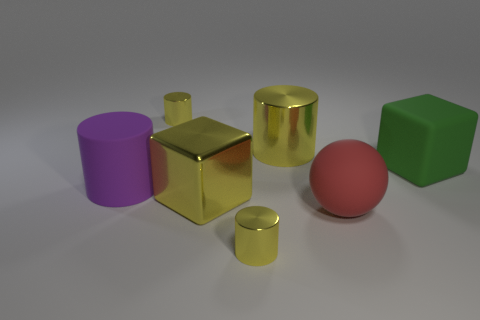How many yellow cylinders must be subtracted to get 1 yellow cylinders? 2 Subtract all yellow blocks. How many yellow cylinders are left? 3 Subtract all big rubber cylinders. How many cylinders are left? 3 Subtract all purple cylinders. How many cylinders are left? 3 Add 3 big rubber cylinders. How many objects exist? 10 Subtract all cubes. How many objects are left? 5 Subtract all cyan cylinders. Subtract all cyan spheres. How many cylinders are left? 4 Subtract 0 blue cylinders. How many objects are left? 7 Subtract all large yellow cylinders. Subtract all big yellow things. How many objects are left? 4 Add 5 purple cylinders. How many purple cylinders are left? 6 